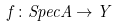<formula> <loc_0><loc_0><loc_500><loc_500>f \colon S p e c A \rightarrow Y</formula> 